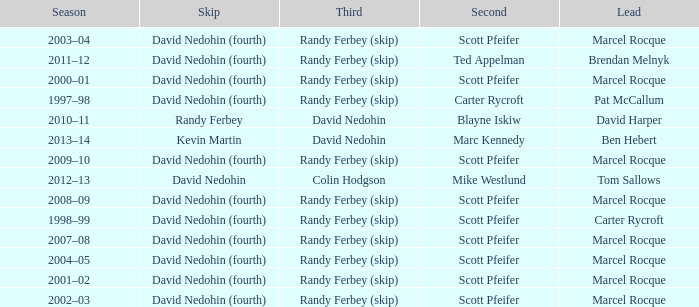Which Second has a Lead of ben hebert? Marc Kennedy. 